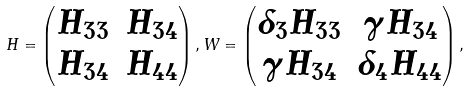<formula> <loc_0><loc_0><loc_500><loc_500>H = \begin{pmatrix} H _ { 3 3 } & H _ { 3 4 } \\ H _ { 3 4 } & H _ { 4 4 } \end{pmatrix} , W = \begin{pmatrix} \delta _ { 3 } H _ { 3 3 } & \gamma H _ { 3 4 } \\ \gamma H _ { 3 4 } & \delta _ { 4 } H _ { 4 4 } \end{pmatrix} ,</formula> 